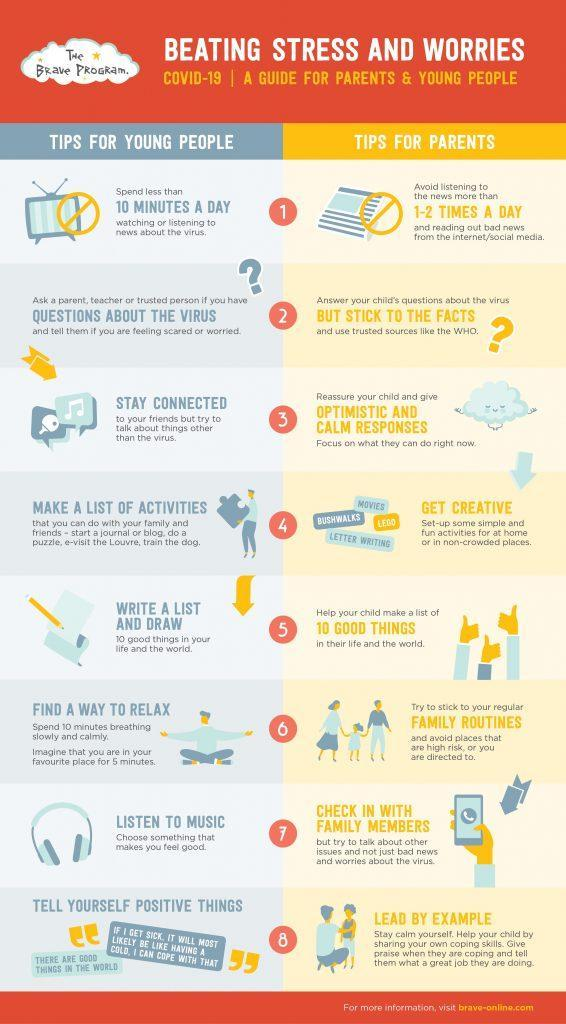How many tips have been given for both young people and parents
Answer the question with a short phrase. 8 How many times to listen to the news is recommended 1-2 times a day how many thumps-up 3 What should we imagine when we try  to relax you are in your favourite place Other than letter writing, what are the other ideas to get creative bushwalks, lego, movies 